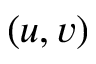Convert formula to latex. <formula><loc_0><loc_0><loc_500><loc_500>( u , v )</formula> 